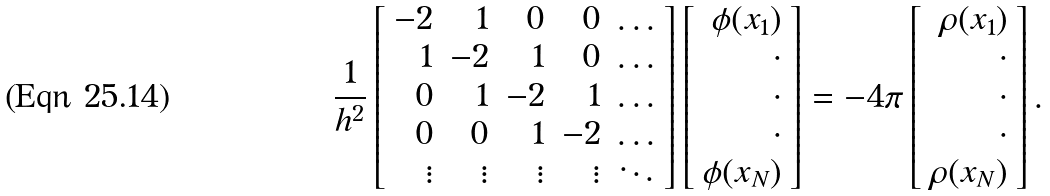<formula> <loc_0><loc_0><loc_500><loc_500>\frac { 1 } { h ^ { 2 } } \left [ \begin{array} { r r r r r } - 2 & 1 & 0 & 0 & \dots \\ 1 & - 2 & 1 & 0 & \dots \\ 0 & 1 & - 2 & 1 & \dots \\ 0 & 0 & 1 & - 2 & \dots \\ \vdots & \vdots & \vdots & \vdots & \ddots \end{array} \right ] \left [ \begin{array} { r } \phi ( x _ { 1 } ) \\ \cdot \\ \cdot \\ \cdot \\ \phi ( x _ { N } ) \end{array} \right ] = - 4 \pi \left [ \begin{array} { r } \rho ( x _ { 1 } ) \\ \cdot \\ \cdot \\ \cdot \\ \rho ( x _ { N } ) \end{array} \right ] .</formula> 